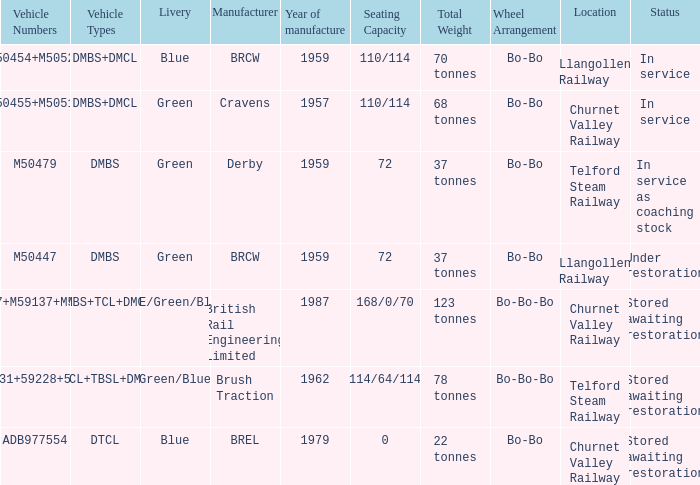What status is the vehicle types of dmbs+tcl+dmcl? Stored awaiting restoration. Parse the table in full. {'header': ['Vehicle Numbers', 'Vehicle Types', 'Livery', 'Manufacturer', 'Year of manufacture', 'Seating Capacity', 'Total Weight', 'Wheel Arrangement', 'Location', 'Status'], 'rows': [['M50454+M50528', 'DMBS+DMCL', 'Blue', 'BRCW', '1959', '110/114', '70 tonnes', 'Bo-Bo', 'Llangollen Railway', 'In service'], ['M50455+M50517', 'DMBS+DMCL', 'Green', 'Cravens', '1957', '110/114', '68 tonnes', 'Bo-Bo', 'Churnet Valley Railway', 'In service'], ['M50479', 'DMBS', 'Green', 'Derby', '1959', '72', '37 tonnes', 'Bo-Bo', 'Telford Steam Railway', 'In service as coaching stock'], ['M50447', 'DMBS', 'Green', 'BRCW', '1959', '72', '37 tonnes', 'Bo-Bo', 'Llangollen Railway', 'Under restoration'], ['53437+M59137+M53494', 'DMBS+TCL+DMCL', 'NSE/Green/Blue', 'British Rail Engineering Limited', '1987', '168/0/70', '123 tonnes', 'Bo-Bo-Bo', 'Churnet Valley Railway', 'Stored awaiting restoration'], ['M50531+59228+53556', 'DMCL+TBSL+DMCL', 'Green/Blue', 'Brush Traction', '1962', '114/64/114', '78 tonnes', 'Bo-Bo-Bo', 'Telford Steam Railway', 'Stored awaiting restoration'], ['ADB977554', 'DTCL', 'Blue', 'BREL', '1979', '0', '22 tonnes', 'Bo-Bo', 'Churnet Valley Railway', 'Stored awaiting restoration']]} 